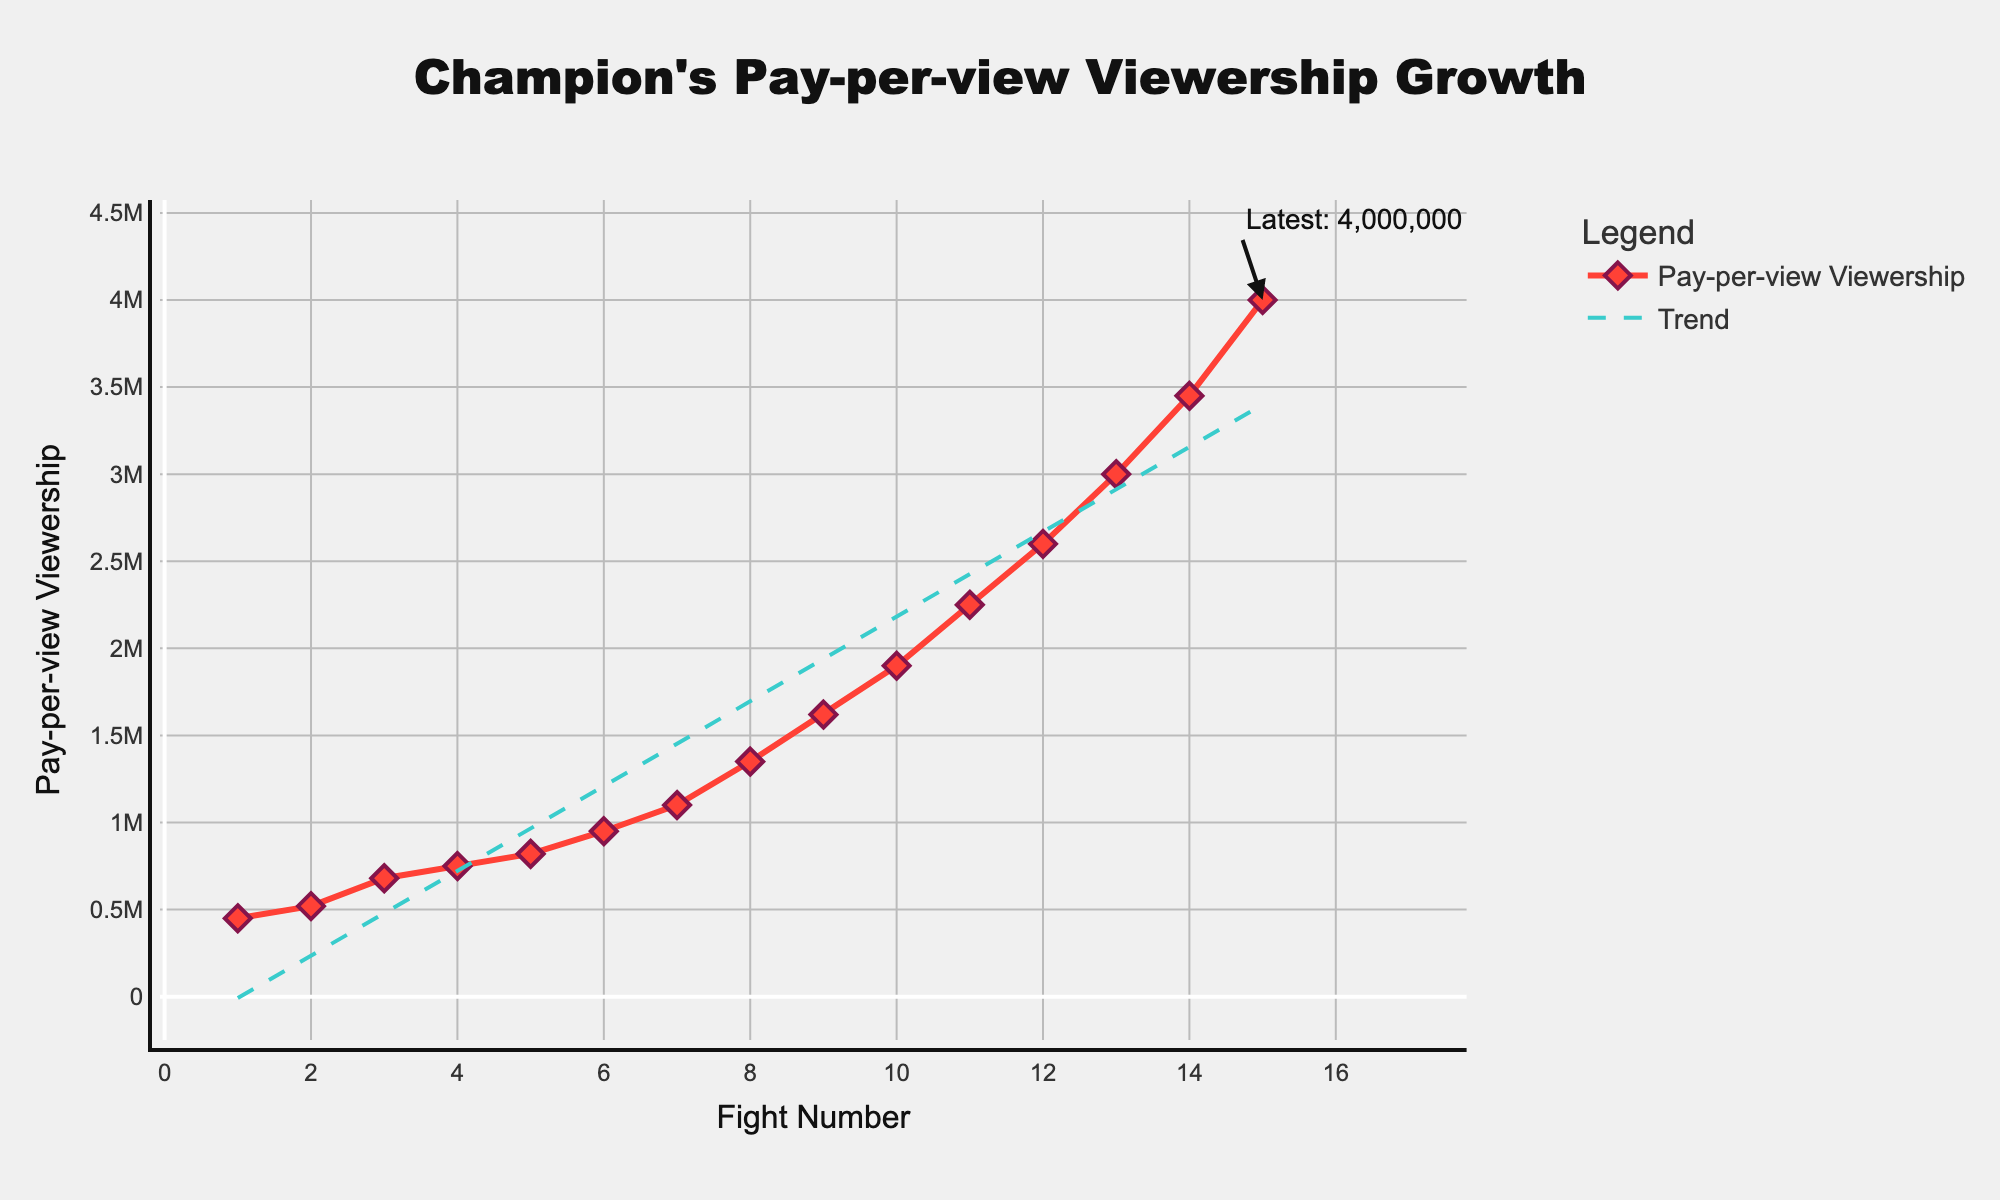What's the trend in Pay-per-view viewership over the 15 fights? The trend line in the plot helps visualize the overall trend. It shows a steady increase in viewership as the fight numbers increase. By examining the green dashed trend line, you can see that the growth is positive and consistent.
Answer: Increasing trend How does the viewership of the 10th fight compare to the 1st fight? Look at the viewership values at the 10th fight and first fight on the x-axis. The 1st fight has a viewership of 450,000, and the 10th fight has 1,900,000. The viewership has significantly increased by 1,450,000.
Answer: Significant increase Which fight had the highest pay-per-view viewership and what was the value? By examining the plot, the highest data point on the y-axis corresponds to the 15th fight. The annotation indicates this value as 4,000,000.
Answer: 15th fight, 4,000,000 What's the average pay-per-view viewership for the first 5 fights? Extract the viewership values of the first 5 fights: (450000, 520000, 680000, 750000, 820000). Add them up to get 3,220,000. Divide by 5 to get the average: 3,220,000 / 5 = 644,000.
Answer: 644,000 Did any fights experience a decline in viewership compared to the previous one? By following the line plot from left (first fight) to right (last fight), each point is higher than the previous, indicating there was no decline in viewership in any fight.
Answer: No decline How many times did the viewership exceed 1 million? Look at the y-axis values and identify the data points that are above 1,000,000. From fights 7 to 15, the viewership exceeded 1 million which totals to 9 fights.
Answer: 9 times What’s the difference in viewership between fight number 5 and fight number 13? Identify the viewership for fights 5 and 13 from the x-axis labels: fight 5 (820,000) and fight 13 (3,000,000). Calculate the difference: 3,000,000 - 820,000 = 2,180,000.
Answer: 2,180,000 Which visual element distinguishes the trend line from the viewership data line? There are two lines, one solid (viewership data) and one dashed (trend line). The viewership data line is red, while the trend line is green and dashed.
Answer: Dashed green line for trend 